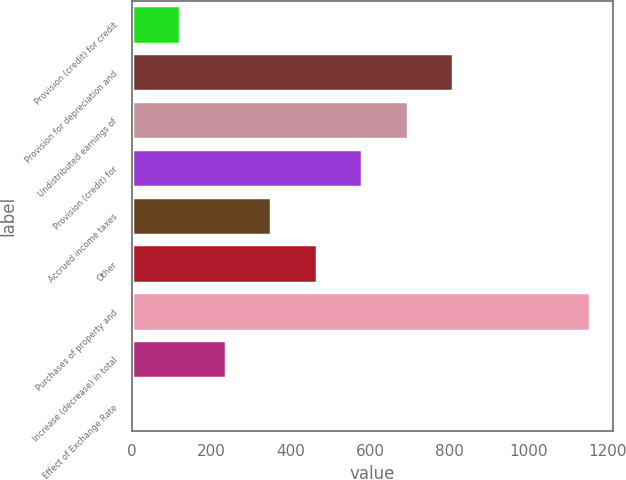<chart> <loc_0><loc_0><loc_500><loc_500><bar_chart><fcel>Provision (credit) for credit<fcel>Provision for depreciation and<fcel>Undistributed earnings of<fcel>Provision (credit) for<fcel>Accrued income taxes<fcel>Other<fcel>Purchases of property and<fcel>Increase (decrease) in total<fcel>Effect of Exchange Rate<nl><fcel>120.38<fcel>810.26<fcel>695.28<fcel>580.3<fcel>350.34<fcel>465.32<fcel>1155.2<fcel>235.36<fcel>5.4<nl></chart> 